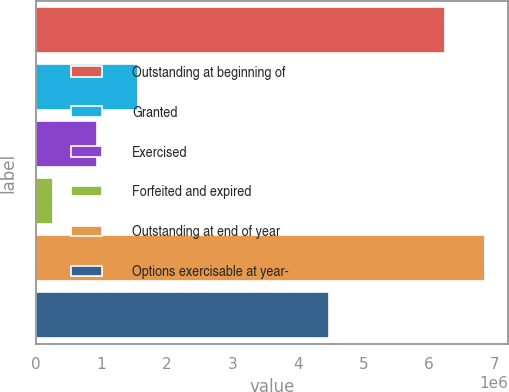Convert chart to OTSL. <chart><loc_0><loc_0><loc_500><loc_500><bar_chart><fcel>Outstanding at beginning of<fcel>Granted<fcel>Exercised<fcel>Forfeited and expired<fcel>Outstanding at end of year<fcel>Options exercisable at year-<nl><fcel>6.23481e+06<fcel>1.55234e+06<fcel>931741<fcel>257032<fcel>6.85541e+06<fcel>4.46448e+06<nl></chart> 